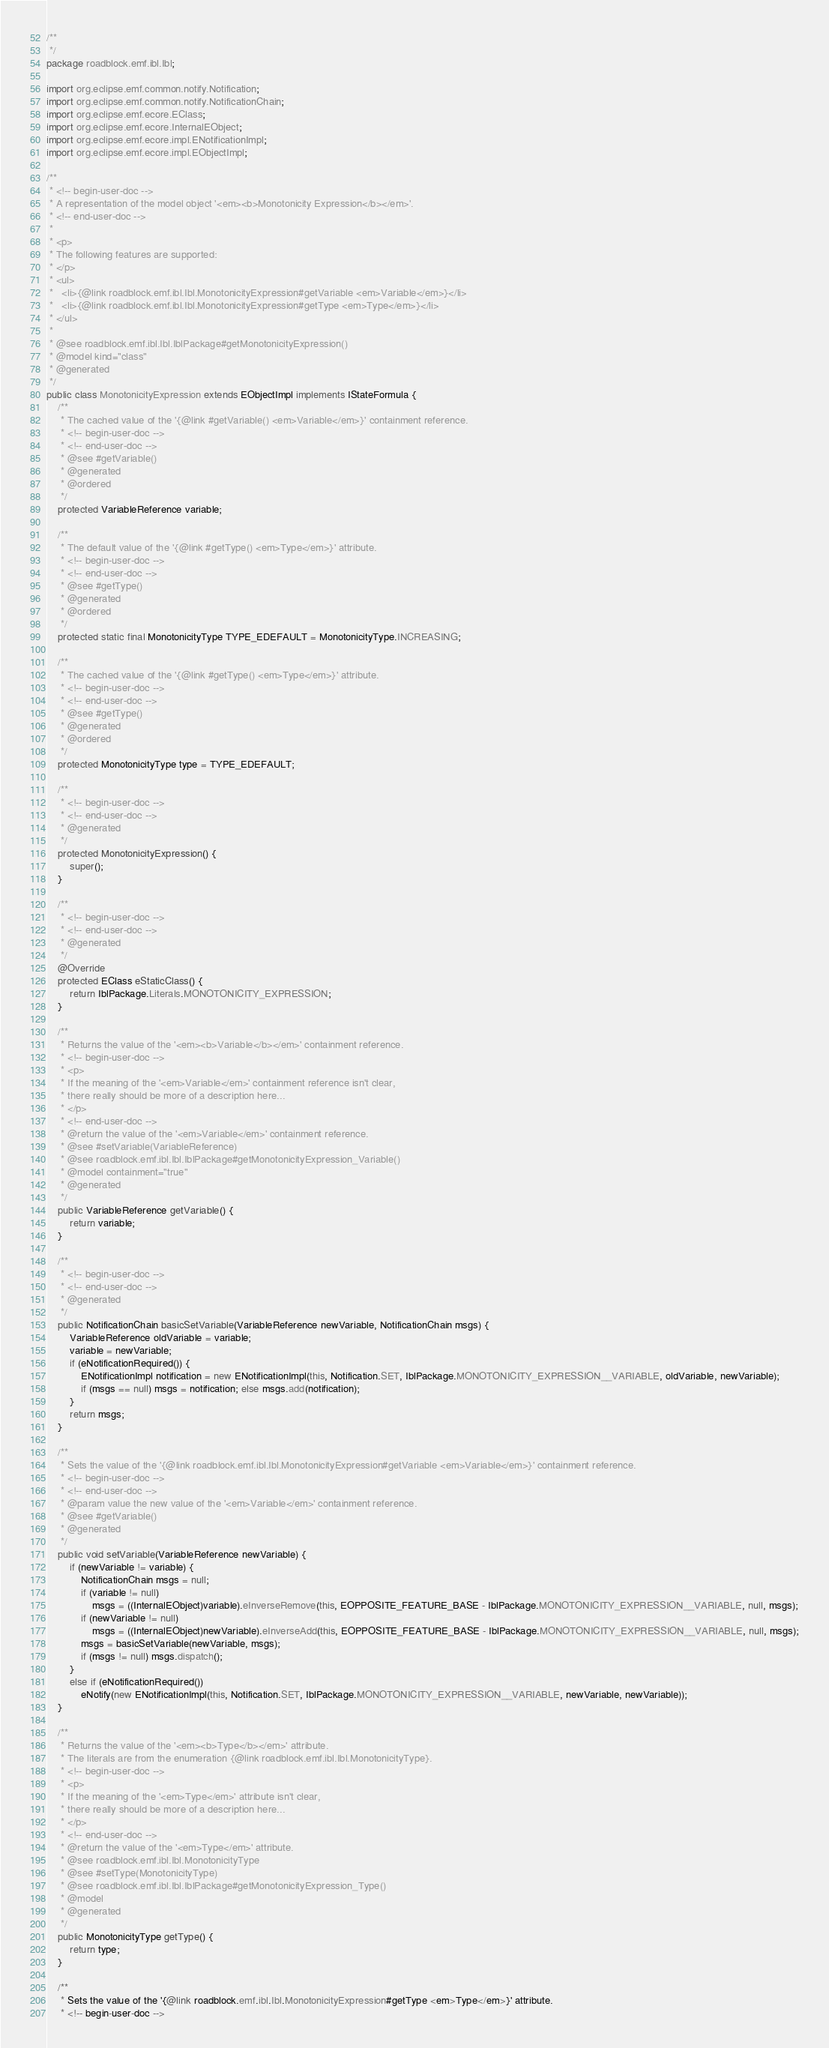Convert code to text. <code><loc_0><loc_0><loc_500><loc_500><_Java_>/**
 */
package roadblock.emf.ibl.Ibl;

import org.eclipse.emf.common.notify.Notification;
import org.eclipse.emf.common.notify.NotificationChain;
import org.eclipse.emf.ecore.EClass;
import org.eclipse.emf.ecore.InternalEObject;
import org.eclipse.emf.ecore.impl.ENotificationImpl;
import org.eclipse.emf.ecore.impl.EObjectImpl;

/**
 * <!-- begin-user-doc -->
 * A representation of the model object '<em><b>Monotonicity Expression</b></em>'.
 * <!-- end-user-doc -->
 *
 * <p>
 * The following features are supported:
 * </p>
 * <ul>
 *   <li>{@link roadblock.emf.ibl.Ibl.MonotonicityExpression#getVariable <em>Variable</em>}</li>
 *   <li>{@link roadblock.emf.ibl.Ibl.MonotonicityExpression#getType <em>Type</em>}</li>
 * </ul>
 *
 * @see roadblock.emf.ibl.Ibl.IblPackage#getMonotonicityExpression()
 * @model kind="class"
 * @generated
 */
public class MonotonicityExpression extends EObjectImpl implements IStateFormula {
	/**
	 * The cached value of the '{@link #getVariable() <em>Variable</em>}' containment reference.
	 * <!-- begin-user-doc -->
	 * <!-- end-user-doc -->
	 * @see #getVariable()
	 * @generated
	 * @ordered
	 */
	protected VariableReference variable;

	/**
	 * The default value of the '{@link #getType() <em>Type</em>}' attribute.
	 * <!-- begin-user-doc -->
	 * <!-- end-user-doc -->
	 * @see #getType()
	 * @generated
	 * @ordered
	 */
	protected static final MonotonicityType TYPE_EDEFAULT = MonotonicityType.INCREASING;

	/**
	 * The cached value of the '{@link #getType() <em>Type</em>}' attribute.
	 * <!-- begin-user-doc -->
	 * <!-- end-user-doc -->
	 * @see #getType()
	 * @generated
	 * @ordered
	 */
	protected MonotonicityType type = TYPE_EDEFAULT;

	/**
	 * <!-- begin-user-doc -->
	 * <!-- end-user-doc -->
	 * @generated
	 */
	protected MonotonicityExpression() {
		super();
	}

	/**
	 * <!-- begin-user-doc -->
	 * <!-- end-user-doc -->
	 * @generated
	 */
	@Override
	protected EClass eStaticClass() {
		return IblPackage.Literals.MONOTONICITY_EXPRESSION;
	}

	/**
	 * Returns the value of the '<em><b>Variable</b></em>' containment reference.
	 * <!-- begin-user-doc -->
	 * <p>
	 * If the meaning of the '<em>Variable</em>' containment reference isn't clear,
	 * there really should be more of a description here...
	 * </p>
	 * <!-- end-user-doc -->
	 * @return the value of the '<em>Variable</em>' containment reference.
	 * @see #setVariable(VariableReference)
	 * @see roadblock.emf.ibl.Ibl.IblPackage#getMonotonicityExpression_Variable()
	 * @model containment="true"
	 * @generated
	 */
	public VariableReference getVariable() {
		return variable;
	}

	/**
	 * <!-- begin-user-doc -->
	 * <!-- end-user-doc -->
	 * @generated
	 */
	public NotificationChain basicSetVariable(VariableReference newVariable, NotificationChain msgs) {
		VariableReference oldVariable = variable;
		variable = newVariable;
		if (eNotificationRequired()) {
			ENotificationImpl notification = new ENotificationImpl(this, Notification.SET, IblPackage.MONOTONICITY_EXPRESSION__VARIABLE, oldVariable, newVariable);
			if (msgs == null) msgs = notification; else msgs.add(notification);
		}
		return msgs;
	}

	/**
	 * Sets the value of the '{@link roadblock.emf.ibl.Ibl.MonotonicityExpression#getVariable <em>Variable</em>}' containment reference.
	 * <!-- begin-user-doc -->
	 * <!-- end-user-doc -->
	 * @param value the new value of the '<em>Variable</em>' containment reference.
	 * @see #getVariable()
	 * @generated
	 */
	public void setVariable(VariableReference newVariable) {
		if (newVariable != variable) {
			NotificationChain msgs = null;
			if (variable != null)
				msgs = ((InternalEObject)variable).eInverseRemove(this, EOPPOSITE_FEATURE_BASE - IblPackage.MONOTONICITY_EXPRESSION__VARIABLE, null, msgs);
			if (newVariable != null)
				msgs = ((InternalEObject)newVariable).eInverseAdd(this, EOPPOSITE_FEATURE_BASE - IblPackage.MONOTONICITY_EXPRESSION__VARIABLE, null, msgs);
			msgs = basicSetVariable(newVariable, msgs);
			if (msgs != null) msgs.dispatch();
		}
		else if (eNotificationRequired())
			eNotify(new ENotificationImpl(this, Notification.SET, IblPackage.MONOTONICITY_EXPRESSION__VARIABLE, newVariable, newVariable));
	}

	/**
	 * Returns the value of the '<em><b>Type</b></em>' attribute.
	 * The literals are from the enumeration {@link roadblock.emf.ibl.Ibl.MonotonicityType}.
	 * <!-- begin-user-doc -->
	 * <p>
	 * If the meaning of the '<em>Type</em>' attribute isn't clear,
	 * there really should be more of a description here...
	 * </p>
	 * <!-- end-user-doc -->
	 * @return the value of the '<em>Type</em>' attribute.
	 * @see roadblock.emf.ibl.Ibl.MonotonicityType
	 * @see #setType(MonotonicityType)
	 * @see roadblock.emf.ibl.Ibl.IblPackage#getMonotonicityExpression_Type()
	 * @model
	 * @generated
	 */
	public MonotonicityType getType() {
		return type;
	}

	/**
	 * Sets the value of the '{@link roadblock.emf.ibl.Ibl.MonotonicityExpression#getType <em>Type</em>}' attribute.
	 * <!-- begin-user-doc --></code> 